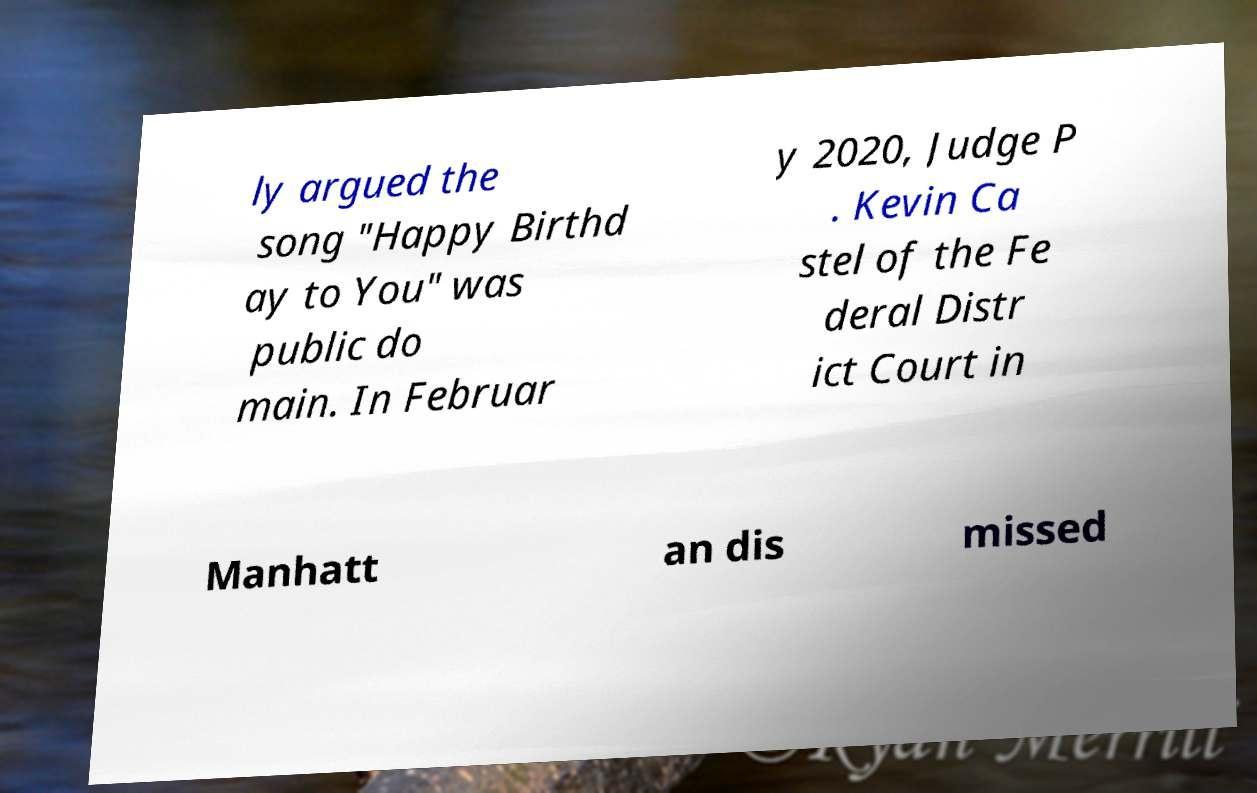Can you accurately transcribe the text from the provided image for me? ly argued the song "Happy Birthd ay to You" was public do main. In Februar y 2020, Judge P . Kevin Ca stel of the Fe deral Distr ict Court in Manhatt an dis missed 